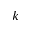Convert formula to latex. <formula><loc_0><loc_0><loc_500><loc_500>k</formula> 